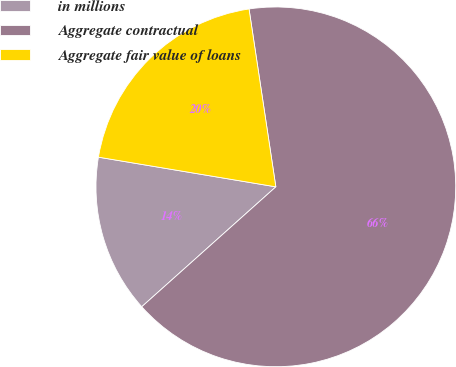Convert chart. <chart><loc_0><loc_0><loc_500><loc_500><pie_chart><fcel>in millions<fcel>Aggregate contractual<fcel>Aggregate fair value of loans<nl><fcel>14.25%<fcel>65.77%<fcel>19.98%<nl></chart> 